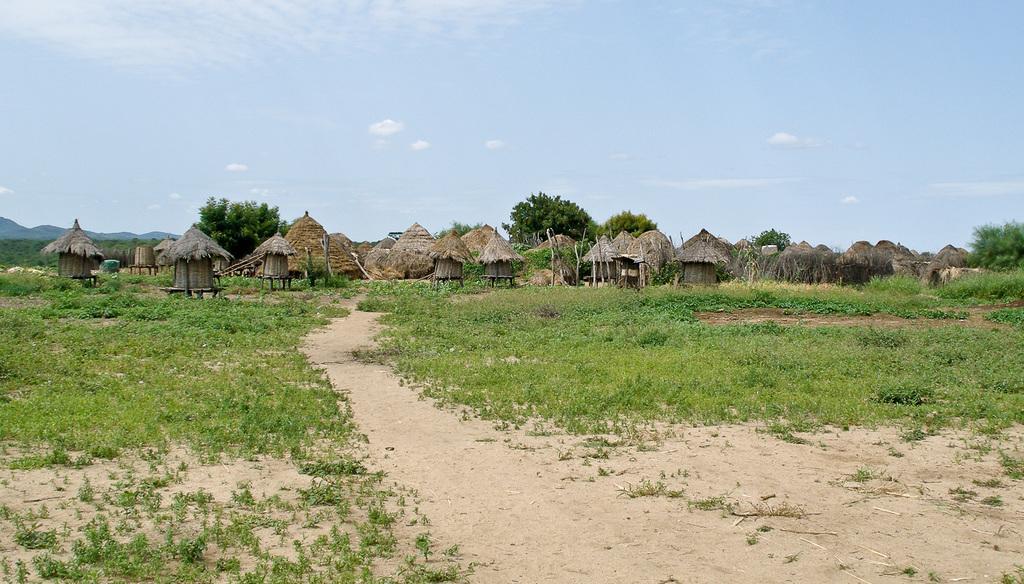In one or two sentences, can you explain what this image depicts? In this image, we can see some plants on the ground. There are trees and some huts in the middle of the image. In the background of the image, there is a sky. 